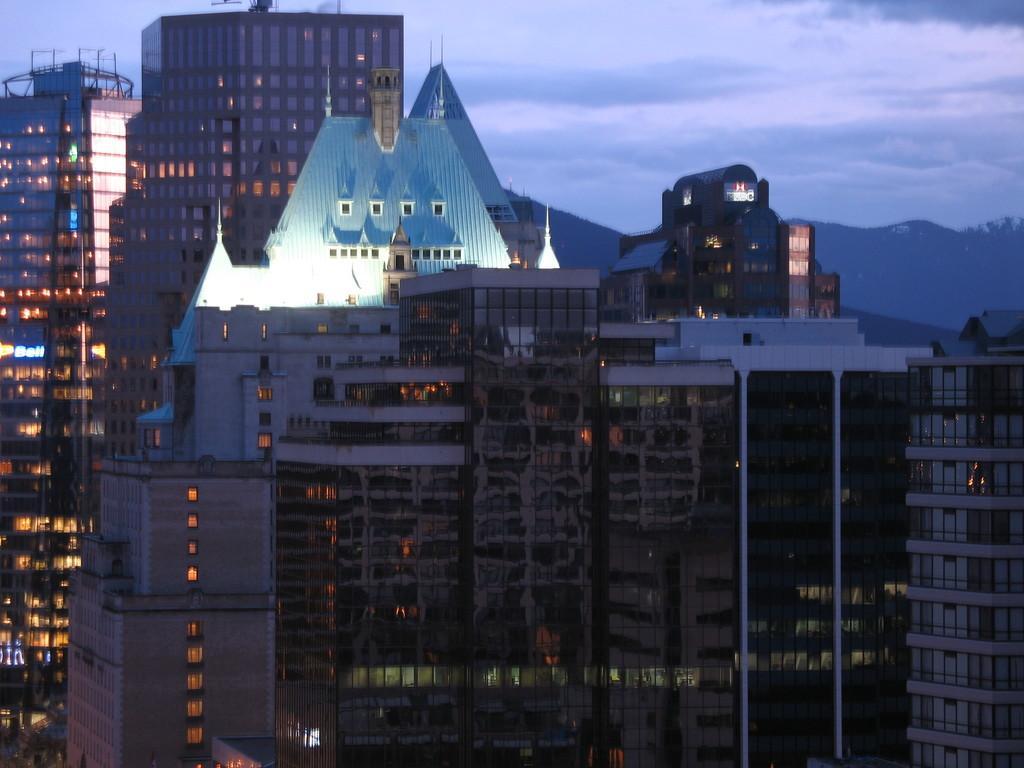In one or two sentences, can you explain what this image depicts? In this picture we can see many buildings. In the background we can see trees and mountains. At the top we can see sky and clouds. 